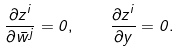Convert formula to latex. <formula><loc_0><loc_0><loc_500><loc_500>\frac { \partial z ^ { i } } { \partial \bar { w } ^ { j } } = 0 , \quad \frac { \partial z ^ { i } } { \partial y } = 0 .</formula> 